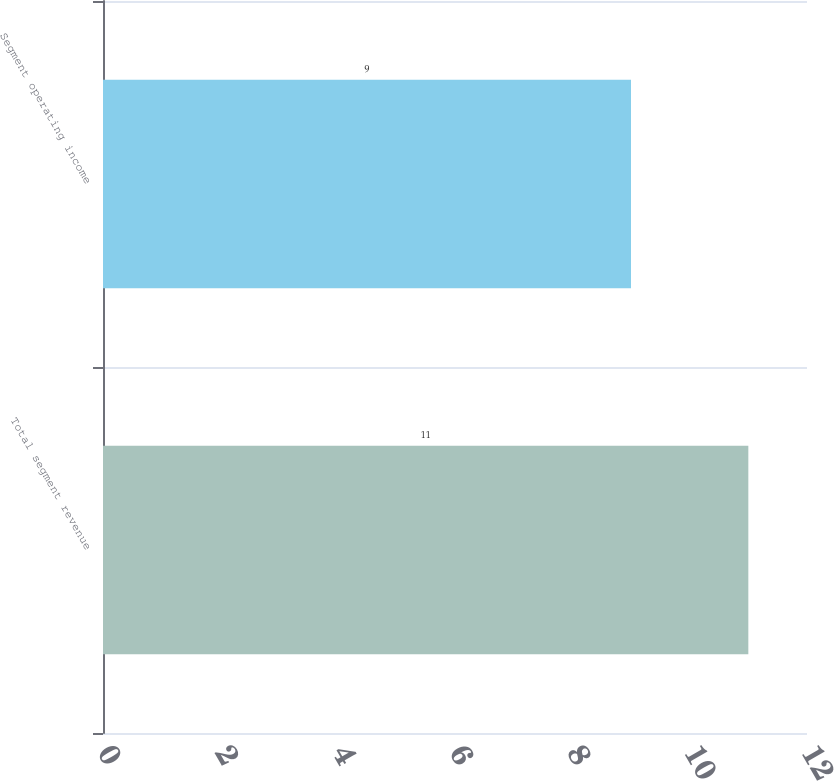Convert chart. <chart><loc_0><loc_0><loc_500><loc_500><bar_chart><fcel>Total segment revenue<fcel>Segment operating income<nl><fcel>11<fcel>9<nl></chart> 